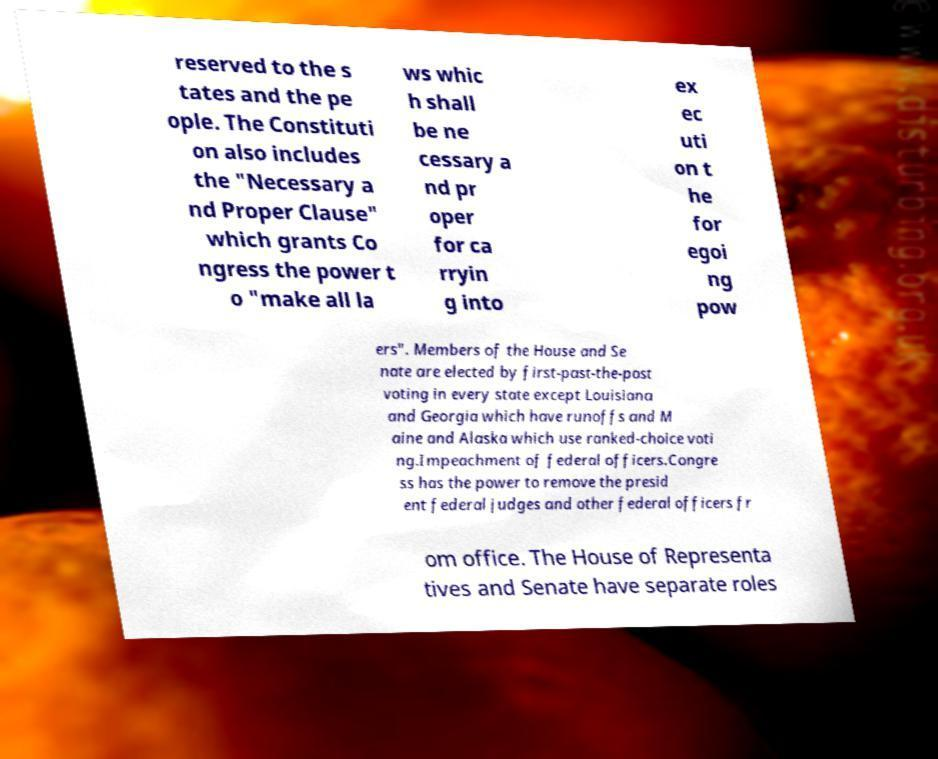Can you accurately transcribe the text from the provided image for me? reserved to the s tates and the pe ople. The Constituti on also includes the "Necessary a nd Proper Clause" which grants Co ngress the power t o "make all la ws whic h shall be ne cessary a nd pr oper for ca rryin g into ex ec uti on t he for egoi ng pow ers". Members of the House and Se nate are elected by first-past-the-post voting in every state except Louisiana and Georgia which have runoffs and M aine and Alaska which use ranked-choice voti ng.Impeachment of federal officers.Congre ss has the power to remove the presid ent federal judges and other federal officers fr om office. The House of Representa tives and Senate have separate roles 